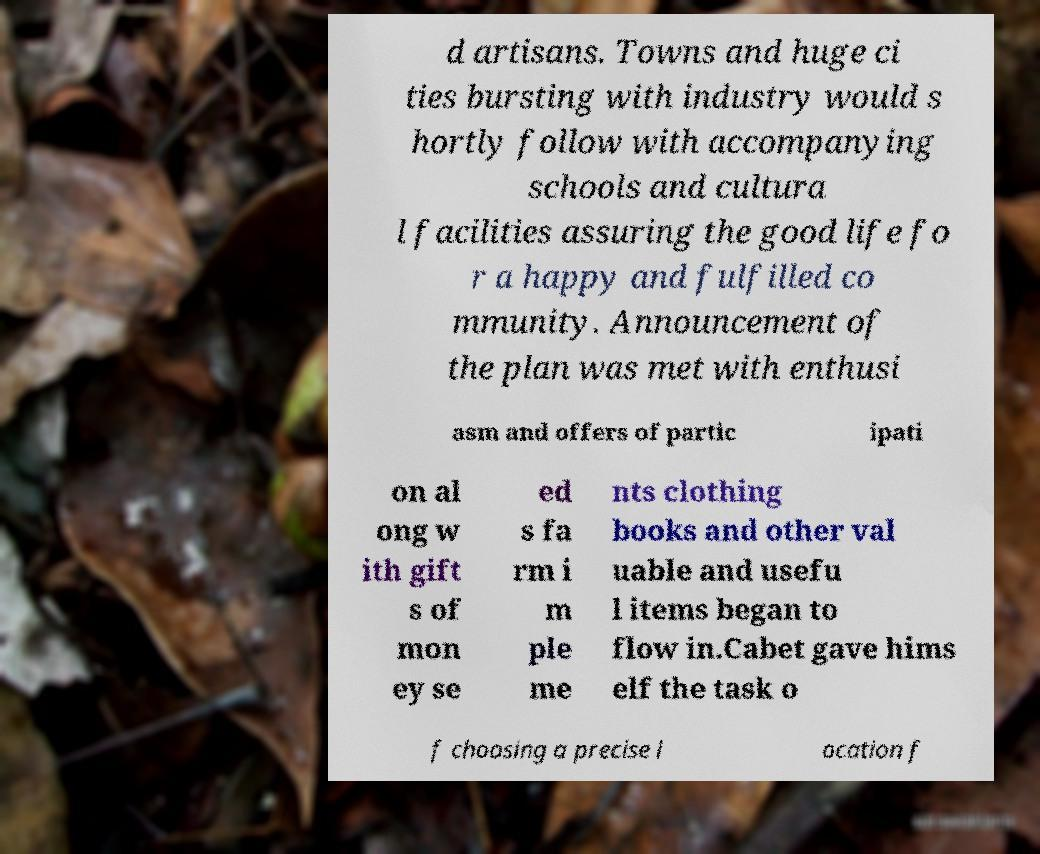For documentation purposes, I need the text within this image transcribed. Could you provide that? d artisans. Towns and huge ci ties bursting with industry would s hortly follow with accompanying schools and cultura l facilities assuring the good life fo r a happy and fulfilled co mmunity. Announcement of the plan was met with enthusi asm and offers of partic ipati on al ong w ith gift s of mon ey se ed s fa rm i m ple me nts clothing books and other val uable and usefu l items began to flow in.Cabet gave hims elf the task o f choosing a precise l ocation f 